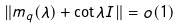Convert formula to latex. <formula><loc_0><loc_0><loc_500><loc_500>\| m _ { q } ( \lambda ) + \cot \lambda I \| = o ( 1 )</formula> 